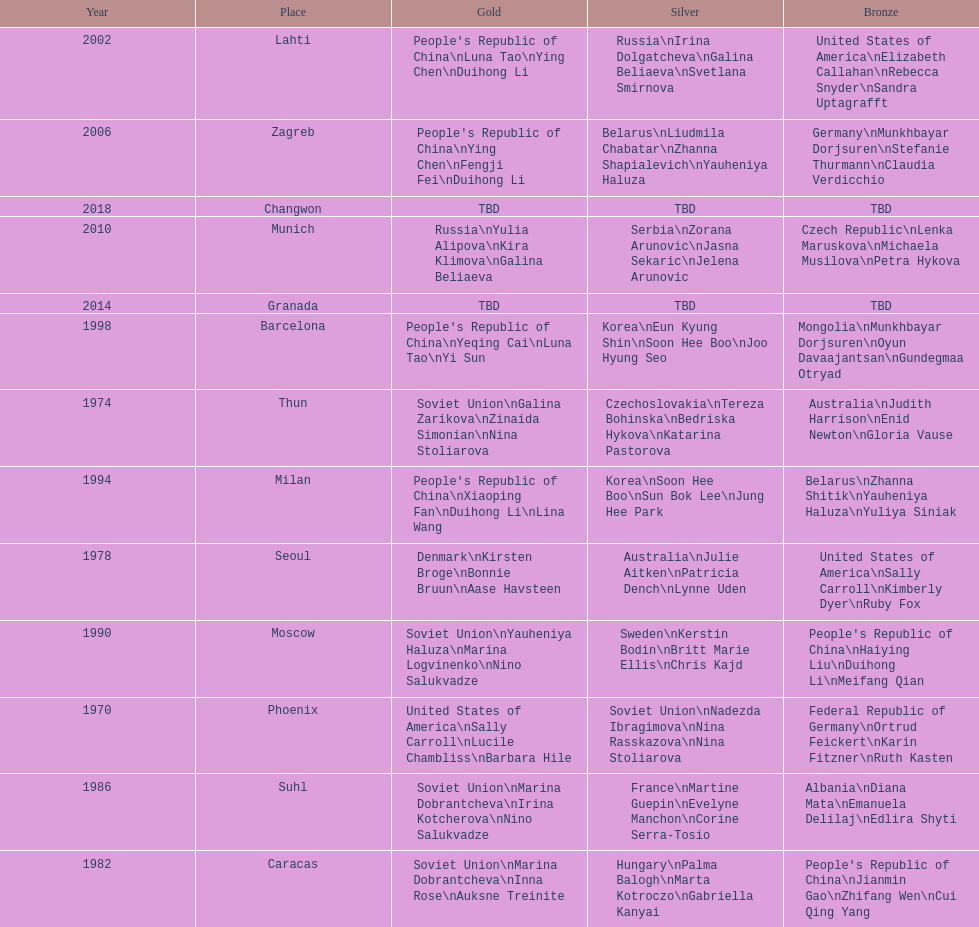What is the first place listed in this chart? Phoenix. 